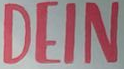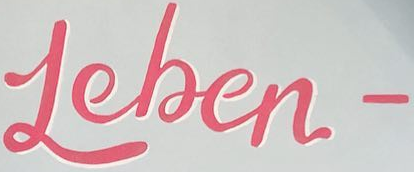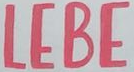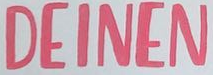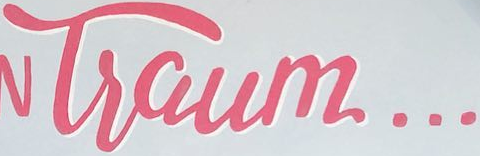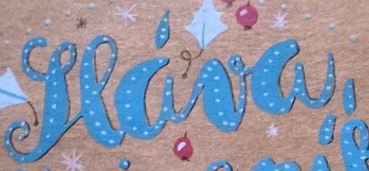What words can you see in these images in sequence, separated by a semicolon? DEIN; Leben-; LEBE; DEINEN; Tsaum...; seáva, 